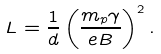<formula> <loc_0><loc_0><loc_500><loc_500>L = \frac { 1 } { d } \left ( \frac { m _ { p } \gamma } { e B } \right ) ^ { 2 } .</formula> 